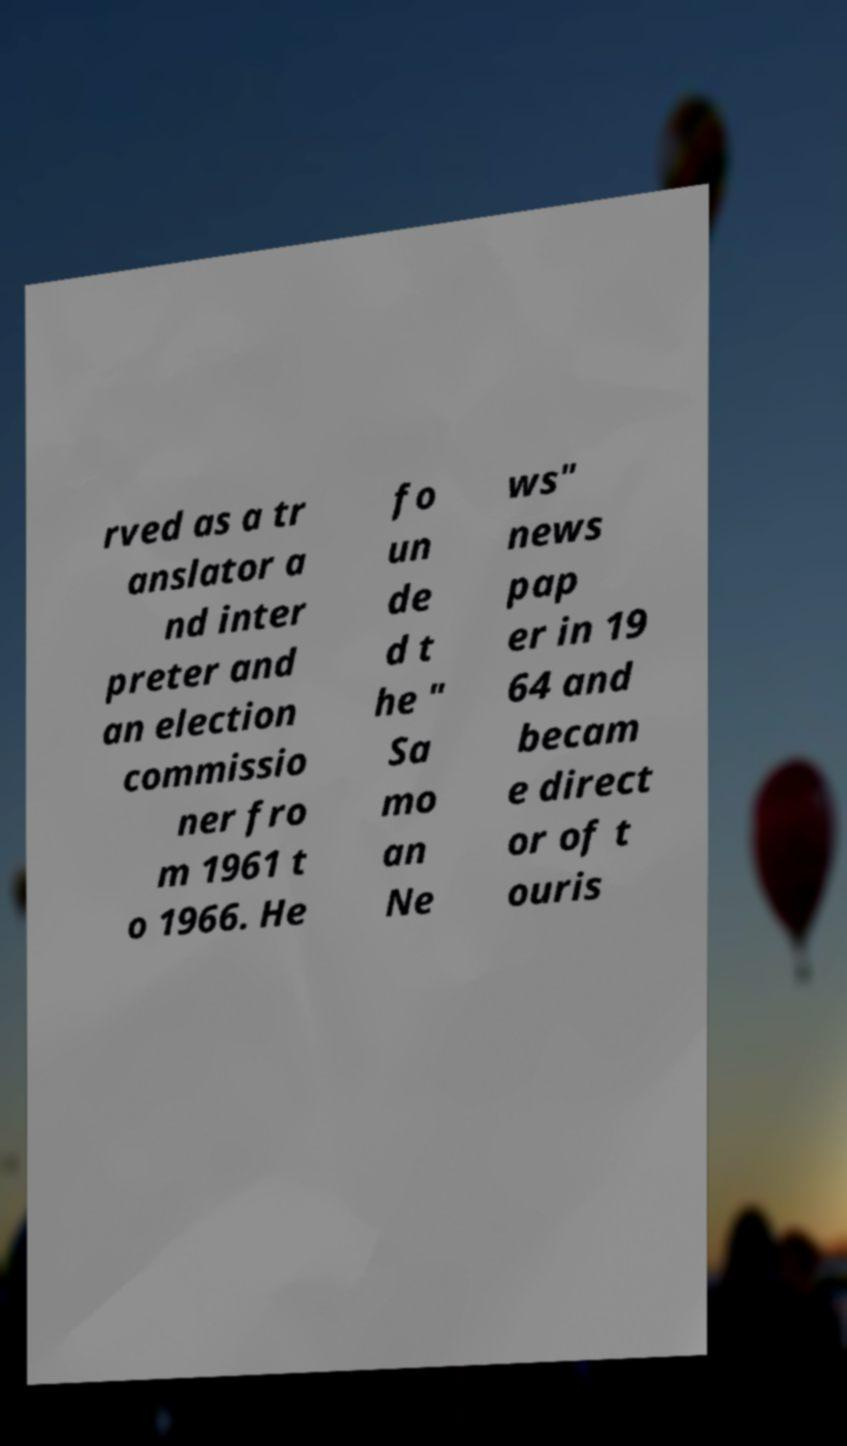For documentation purposes, I need the text within this image transcribed. Could you provide that? rved as a tr anslator a nd inter preter and an election commissio ner fro m 1961 t o 1966. He fo un de d t he " Sa mo an Ne ws" news pap er in 19 64 and becam e direct or of t ouris 